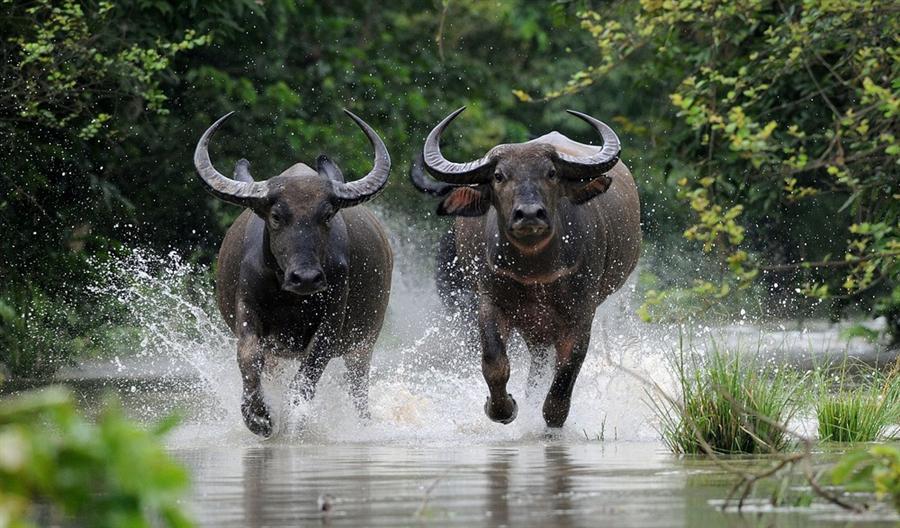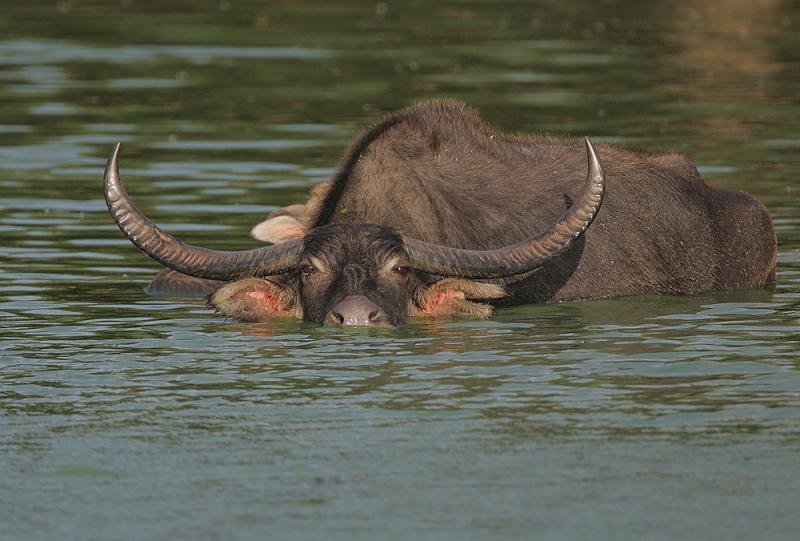The first image is the image on the left, the second image is the image on the right. Considering the images on both sides, is "An image contains a water buffalo partially under water." valid? Answer yes or no. Yes. The first image is the image on the left, the second image is the image on the right. Assess this claim about the two images: "In at least one of the images, a single water buffalo is standing in deep water.". Correct or not? Answer yes or no. Yes. 